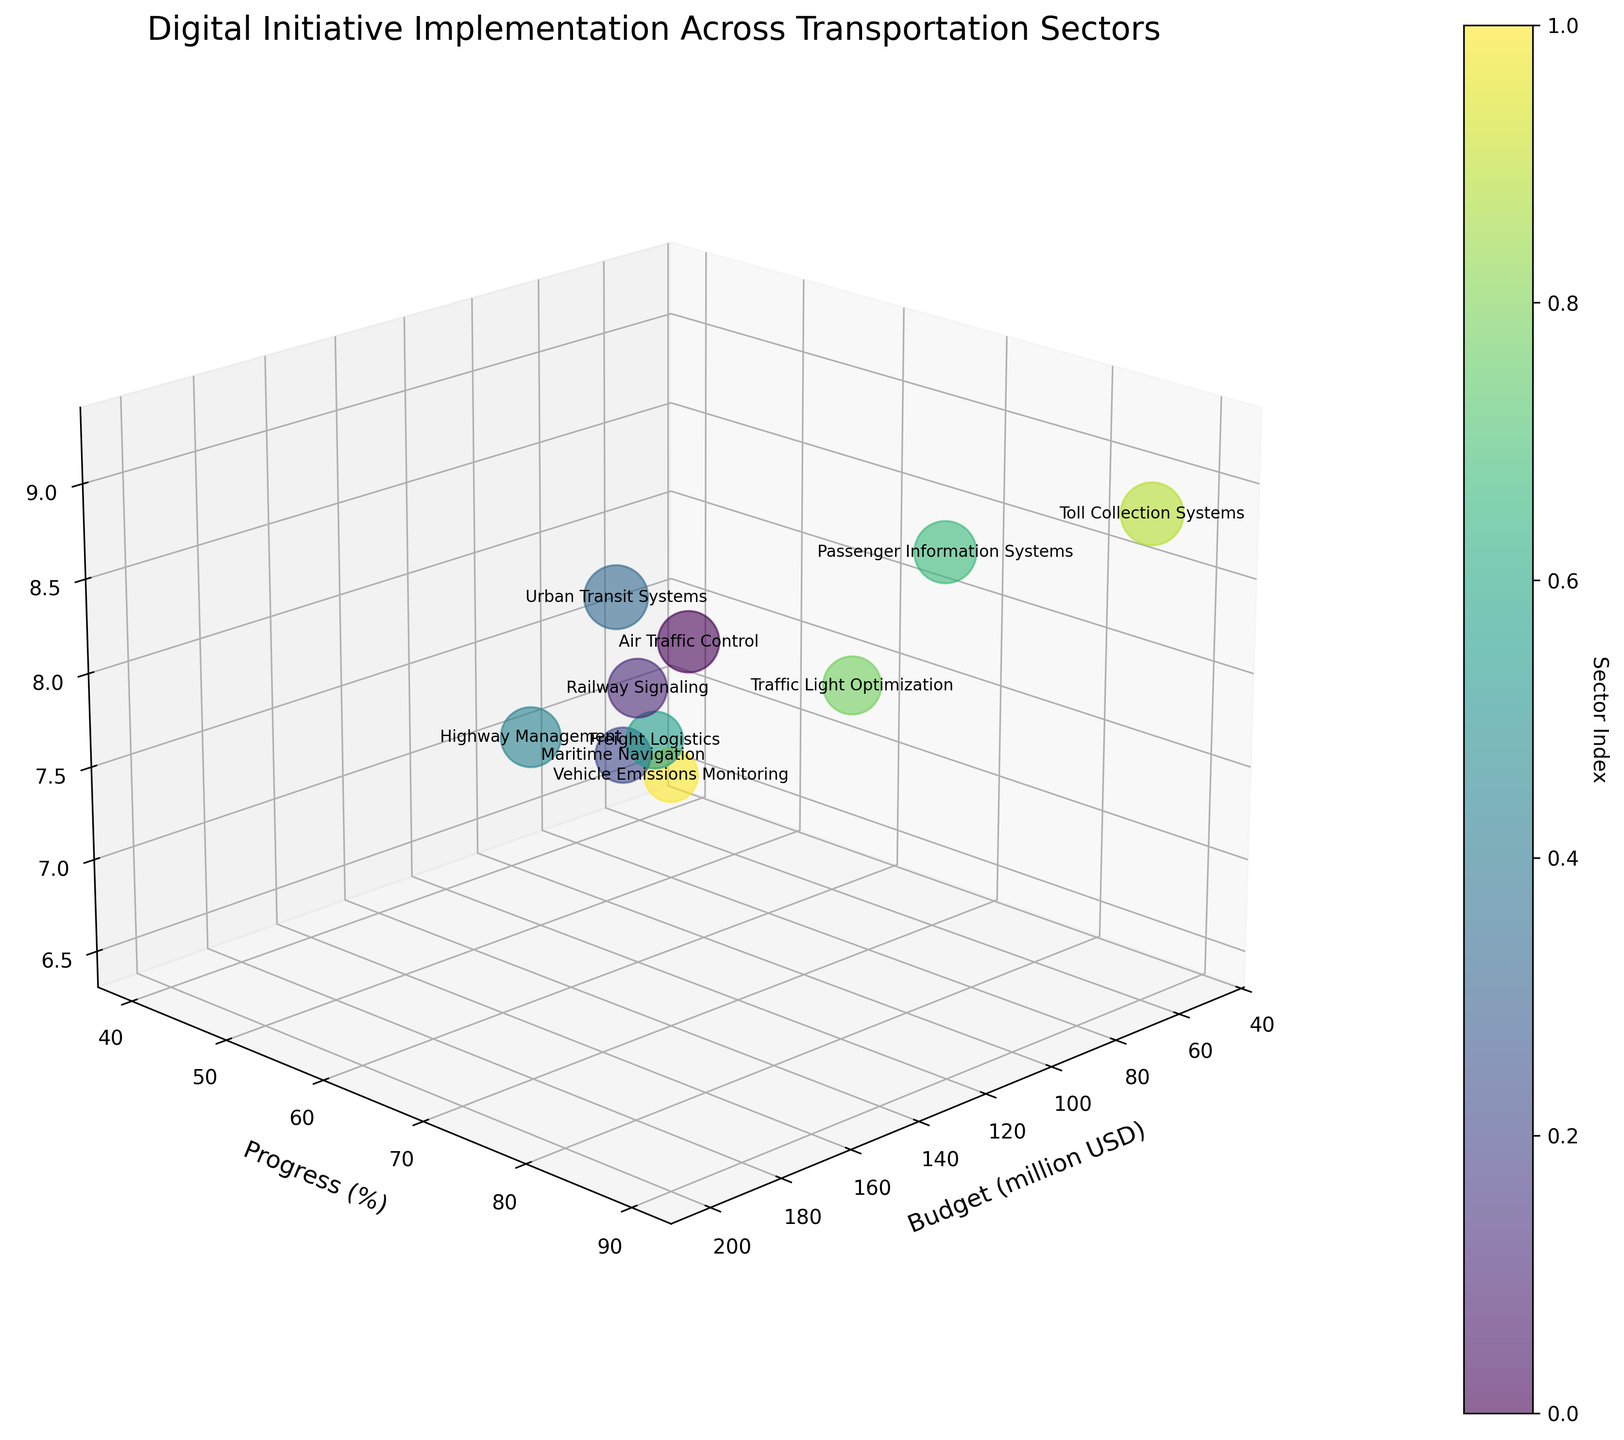When will Urban Transit Systems achieve 100% progress based on the current trend? Urban Transit Systems has a 85% progress with a budget of 200 million USD, observe that it is one of the highest progress. However, estimating when exactly it will reach 100% requires additional time-related data which is not available in the figure.
Answer: Not determinable from the figure Which sector has the highest projected impact? By checking the Z-axis (Projected Impact) and looking for the highest value on it, Urban Transit Systems has the highest projected impact of 9.2.
Answer: Urban Transit Systems What is the budget allocation for Traffic Light Optimization? By locating Traffic Light Optimization bubble on the X-axis (Budget), and reading off the budget value, Traffic Light Optimization has a budget of 70 million USD.
Answer: 70 million USD What is the least progressed sector? By identifying the bubble lowest on the Y-axis (Progress), Vehicle Emissions Monitoring is the least progressed at 40%.
Answer: Vehicle Emissions Monitoring Compare the budget and progress of Air Traffic Control and Highway Management. Which has a higher budget and which has higher progress? Air Traffic Control has a budget of 150 million USD and a progress of 75%. Highway Management has a budget of 180 million USD and a progress of 70%. Comparing both, Highway Management has a higher budget, but Air Traffic Control has higher progress.
Answer: Highway Management has a higher budget, Air Traffic Control has higher progress Which sector has the smallest bubble? How can you infer its projected impact? The smallest bubble can be inferred from the visual size, and by checking the Z-axis value of the smallest bubble. Vehicle Emissions Monitoring appears to have the smallest bubble, thus the lowest projected impact of 6.5.
Answer: Vehicle Emissions Monitoring What is the average budget and projected impact for the sectors with progress above 80%? Identifying the sectors with more than 80% progress (Urban Transit Systems, Passenger Information Systems, and Toll Collection Systems), their budgets are 200, 90, and 60 million USD respectively, and their projected impacts are 9.2, 8.7, and 8.9. The average budget = (200 + 90 + 60) / 3 = 116.67 million USD. The average projected impact = (9.2 + 8.7 + 8.9) / 3 ≈ 8.93.
Answer: 116.67 million USD, 8.93 Which two sectors are closest to each other in terms of progress? Checking the Y-axis (Progress), Railway Signaling at 60% and Traffic Light Optimization at 65% are the two sectors with the closest progress values.
Answer: Railway Signaling and Traffic Light Optimization List all sectors with their projected impact greater than 8.0. By identifying bubbles on the Z-axis with greater than 8.0 projected impact: Air Traffic Control (8.5), Urban Transit Systems (9.2), Highway Management (8.1), Passenger Information Systems (8.7), and Toll Collection Systems (8.9).
Answer: Air Traffic Control, Urban Transit Systems, Highway Management, Passenger Information Systems, and Toll Collection Systems 